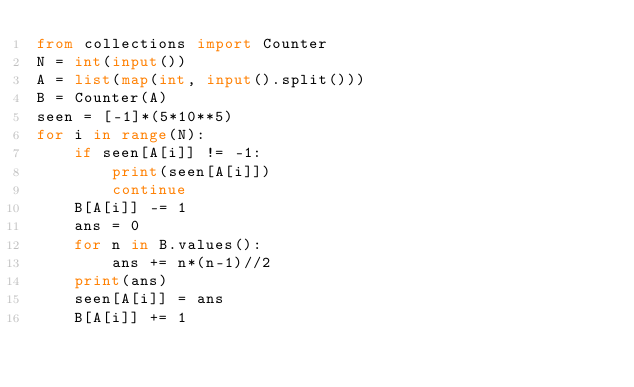Convert code to text. <code><loc_0><loc_0><loc_500><loc_500><_Python_>from collections import Counter
N = int(input())
A = list(map(int, input().split()))
B = Counter(A)
seen = [-1]*(5*10**5)
for i in range(N):
    if seen[A[i]] != -1:
        print(seen[A[i]])
        continue
    B[A[i]] -= 1
    ans = 0
    for n in B.values():
        ans += n*(n-1)//2
    print(ans)
    seen[A[i]] = ans
    B[A[i]] += 1</code> 